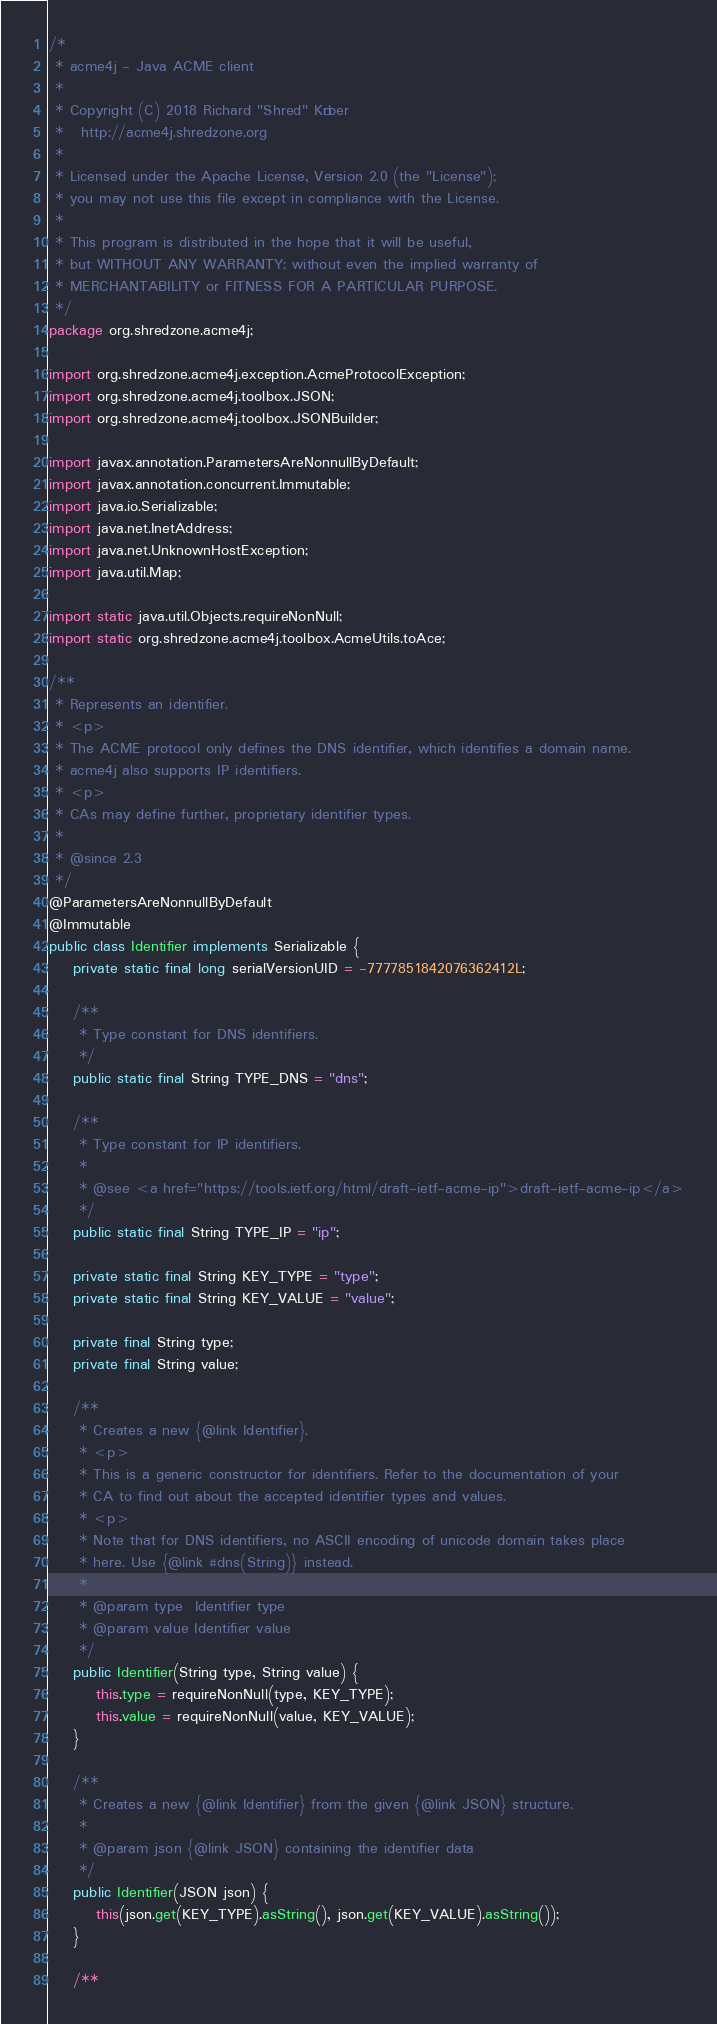<code> <loc_0><loc_0><loc_500><loc_500><_Java_>/*
 * acme4j - Java ACME client
 *
 * Copyright (C) 2018 Richard "Shred" Körber
 *   http://acme4j.shredzone.org
 *
 * Licensed under the Apache License, Version 2.0 (the "License");
 * you may not use this file except in compliance with the License.
 *
 * This program is distributed in the hope that it will be useful,
 * but WITHOUT ANY WARRANTY; without even the implied warranty of
 * MERCHANTABILITY or FITNESS FOR A PARTICULAR PURPOSE.
 */
package org.shredzone.acme4j;

import org.shredzone.acme4j.exception.AcmeProtocolException;
import org.shredzone.acme4j.toolbox.JSON;
import org.shredzone.acme4j.toolbox.JSONBuilder;

import javax.annotation.ParametersAreNonnullByDefault;
import javax.annotation.concurrent.Immutable;
import java.io.Serializable;
import java.net.InetAddress;
import java.net.UnknownHostException;
import java.util.Map;

import static java.util.Objects.requireNonNull;
import static org.shredzone.acme4j.toolbox.AcmeUtils.toAce;

/**
 * Represents an identifier.
 * <p>
 * The ACME protocol only defines the DNS identifier, which identifies a domain name.
 * acme4j also supports IP identifiers.
 * <p>
 * CAs may define further, proprietary identifier types.
 *
 * @since 2.3
 */
@ParametersAreNonnullByDefault
@Immutable
public class Identifier implements Serializable {
    private static final long serialVersionUID = -7777851842076362412L;

    /**
     * Type constant for DNS identifiers.
     */
    public static final String TYPE_DNS = "dns";

    /**
     * Type constant for IP identifiers.
     *
     * @see <a href="https://tools.ietf.org/html/draft-ietf-acme-ip">draft-ietf-acme-ip</a>
     */
    public static final String TYPE_IP = "ip";

    private static final String KEY_TYPE = "type";
    private static final String KEY_VALUE = "value";

    private final String type;
    private final String value;

    /**
     * Creates a new {@link Identifier}.
     * <p>
     * This is a generic constructor for identifiers. Refer to the documentation of your
     * CA to find out about the accepted identifier types and values.
     * <p>
     * Note that for DNS identifiers, no ASCII encoding of unicode domain takes place
     * here. Use {@link #dns(String)} instead.
     *
     * @param type  Identifier type
     * @param value Identifier value
     */
    public Identifier(String type, String value) {
        this.type = requireNonNull(type, KEY_TYPE);
        this.value = requireNonNull(value, KEY_VALUE);
    }

    /**
     * Creates a new {@link Identifier} from the given {@link JSON} structure.
     *
     * @param json {@link JSON} containing the identifier data
     */
    public Identifier(JSON json) {
        this(json.get(KEY_TYPE).asString(), json.get(KEY_VALUE).asString());
    }

    /**</code> 